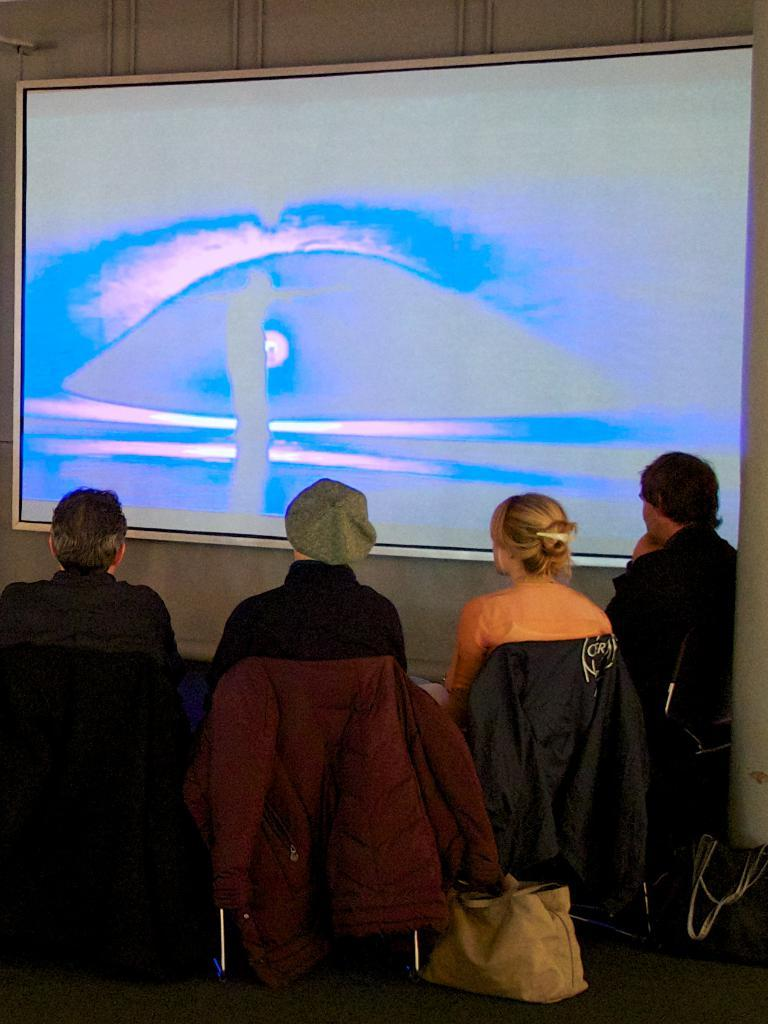What is the main subject of the image? There is a group of people in the image. What can be seen in the background of the image? There are bags on a table in the background. What electronic device is visible in the image? There is a screen visible in the image. What type of infrastructure is present in the image? There are pipes in the image. Can you see any pigs or a goose in the image? No, there are no pigs or a goose present in the image. 